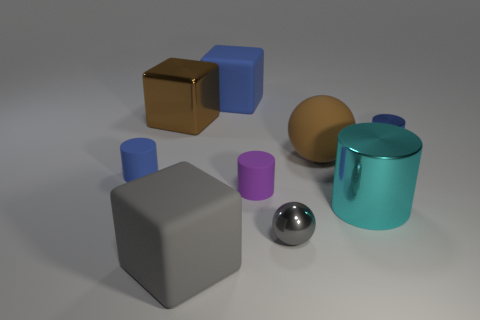There is a tiny purple thing; does it have the same shape as the thing to the left of the brown metal thing?
Provide a short and direct response. Yes. The metallic cylinder that is left of the blue cylinder that is on the right side of the large cube in front of the brown ball is what color?
Give a very brief answer. Cyan. What number of things are either tiny objects that are in front of the tiny blue matte cylinder or things to the right of the big blue block?
Your response must be concise. 5. How many other things are the same color as the large metallic cylinder?
Give a very brief answer. 0. There is a blue rubber object that is on the left side of the large gray rubber cube; does it have the same shape as the big cyan thing?
Provide a short and direct response. Yes. Are there fewer large brown shiny blocks in front of the brown ball than cyan metal things?
Provide a succinct answer. Yes. Is there a blue block that has the same material as the cyan cylinder?
Offer a very short reply. No. What material is the blue object that is the same size as the brown metallic block?
Your answer should be very brief. Rubber. Are there fewer big metal objects on the left side of the tiny purple thing than rubber things that are to the left of the small gray object?
Your answer should be very brief. Yes. What shape is the blue thing that is in front of the large blue matte block and to the left of the tiny blue metallic object?
Ensure brevity in your answer.  Cylinder. 